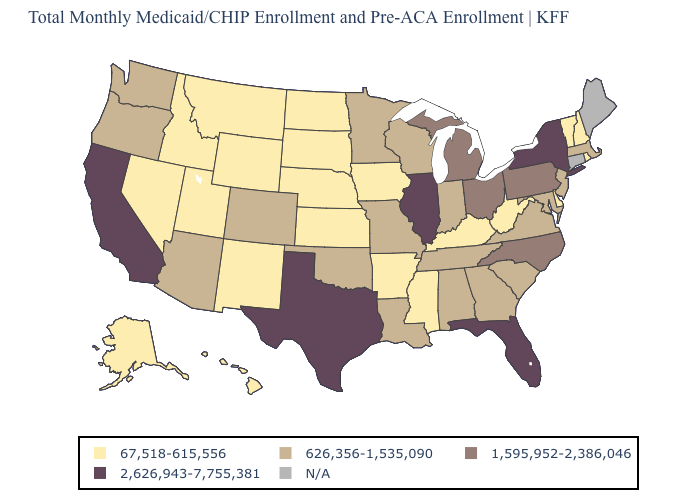Among the states that border Utah , does Wyoming have the lowest value?
Answer briefly. Yes. What is the value of Nebraska?
Be succinct. 67,518-615,556. What is the value of Connecticut?
Be succinct. N/A. Which states have the lowest value in the USA?
Short answer required. Alaska, Arkansas, Delaware, Hawaii, Idaho, Iowa, Kansas, Kentucky, Mississippi, Montana, Nebraska, Nevada, New Hampshire, New Mexico, North Dakota, Rhode Island, South Dakota, Utah, Vermont, West Virginia, Wyoming. What is the lowest value in states that border Idaho?
Quick response, please. 67,518-615,556. Does Missouri have the lowest value in the MidWest?
Be succinct. No. Name the states that have a value in the range 626,356-1,535,090?
Be succinct. Alabama, Arizona, Colorado, Georgia, Indiana, Louisiana, Maryland, Massachusetts, Minnesota, Missouri, New Jersey, Oklahoma, Oregon, South Carolina, Tennessee, Virginia, Washington, Wisconsin. What is the value of South Carolina?
Be succinct. 626,356-1,535,090. What is the value of Georgia?
Give a very brief answer. 626,356-1,535,090. Which states hav the highest value in the Northeast?
Be succinct. New York. Name the states that have a value in the range 626,356-1,535,090?
Keep it brief. Alabama, Arizona, Colorado, Georgia, Indiana, Louisiana, Maryland, Massachusetts, Minnesota, Missouri, New Jersey, Oklahoma, Oregon, South Carolina, Tennessee, Virginia, Washington, Wisconsin. Among the states that border Arizona , which have the lowest value?
Quick response, please. Nevada, New Mexico, Utah. What is the value of Tennessee?
Write a very short answer. 626,356-1,535,090. Is the legend a continuous bar?
Concise answer only. No. 